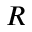<formula> <loc_0><loc_0><loc_500><loc_500>R</formula> 